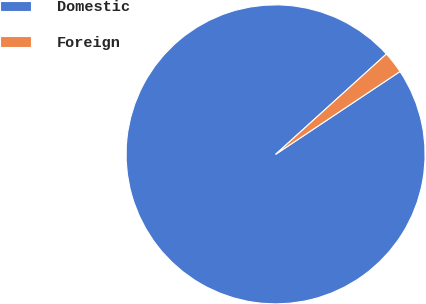Convert chart. <chart><loc_0><loc_0><loc_500><loc_500><pie_chart><fcel>Domestic<fcel>Foreign<nl><fcel>97.64%<fcel>2.36%<nl></chart> 